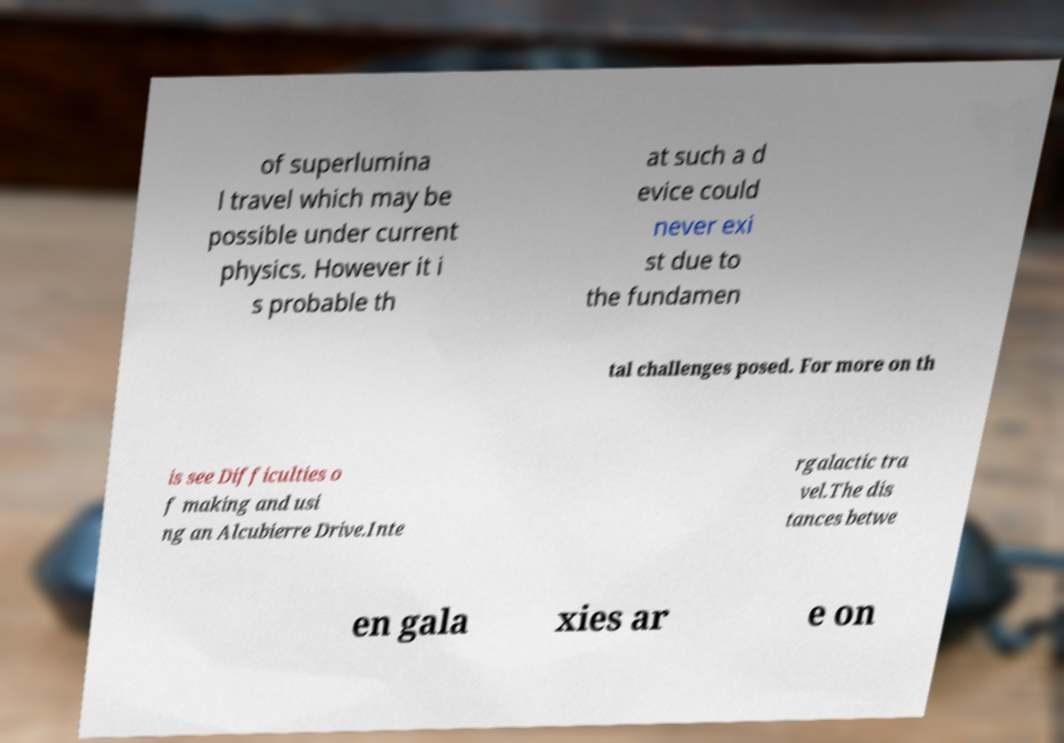Could you extract and type out the text from this image? of superlumina l travel which may be possible under current physics. However it i s probable th at such a d evice could never exi st due to the fundamen tal challenges posed. For more on th is see Difficulties o f making and usi ng an Alcubierre Drive.Inte rgalactic tra vel.The dis tances betwe en gala xies ar e on 